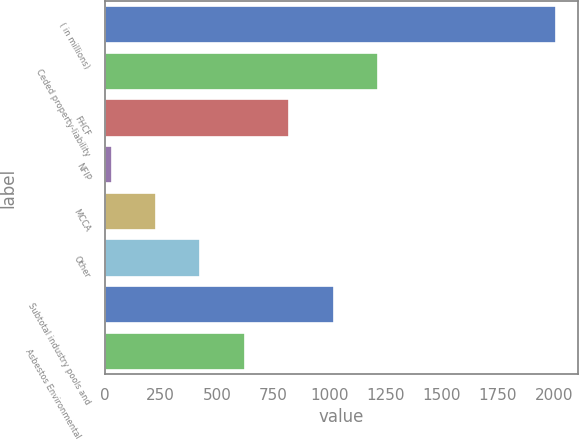Convert chart. <chart><loc_0><loc_0><loc_500><loc_500><bar_chart><fcel>( in millions)<fcel>Ceded property-liability<fcel>FHCF<fcel>NFIP<fcel>MCCA<fcel>Other<fcel>Subtotal industry pools and<fcel>Asbestos Environmental and<nl><fcel>2006<fcel>1216.4<fcel>821.6<fcel>32<fcel>229.4<fcel>426.8<fcel>1019<fcel>624.2<nl></chart> 